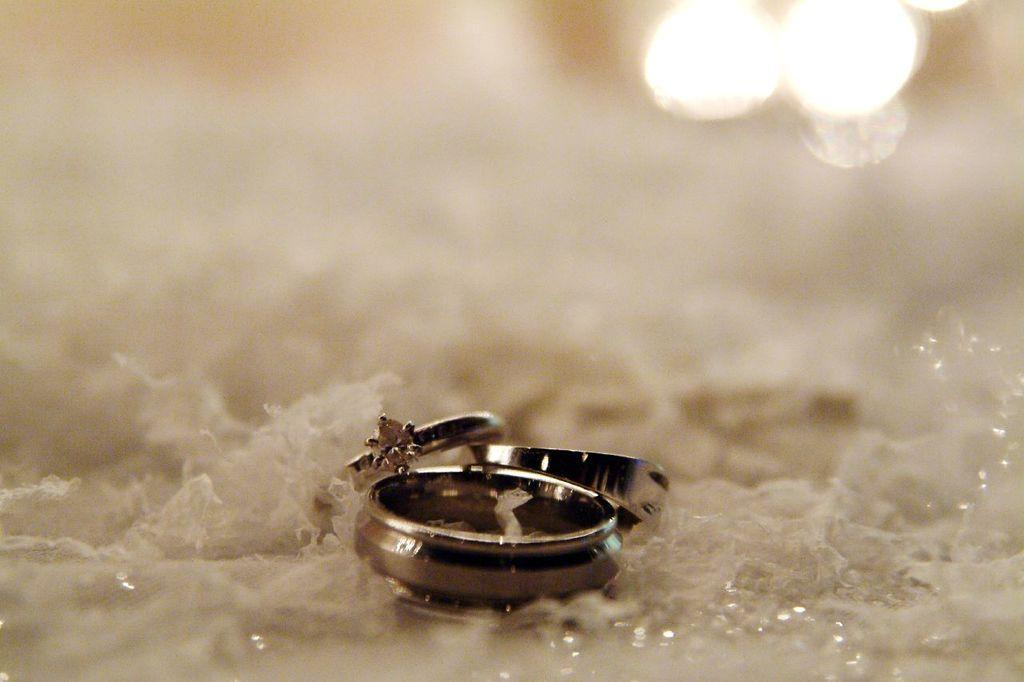How many rings are visible in the image? There are three rings in the image. What is the color of the surface on which the rings are placed? The rings are placed on a white surface. What type of leaf is present in the image? There is no leaf present in the image; it only features three rings on a white surface. How many bears can be seen interacting with the rings in the image? There are no bears present in the image; it only features three rings on a white surface. 